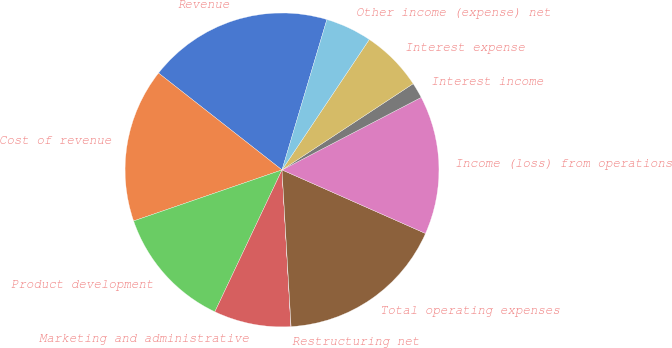Convert chart to OTSL. <chart><loc_0><loc_0><loc_500><loc_500><pie_chart><fcel>Revenue<fcel>Cost of revenue<fcel>Product development<fcel>Marketing and administrative<fcel>Restructuring net<fcel>Total operating expenses<fcel>Income (loss) from operations<fcel>Interest income<fcel>Interest expense<fcel>Other income (expense) net<nl><fcel>19.03%<fcel>15.86%<fcel>12.69%<fcel>7.94%<fcel>0.02%<fcel>17.44%<fcel>14.28%<fcel>1.61%<fcel>6.36%<fcel>4.77%<nl></chart> 